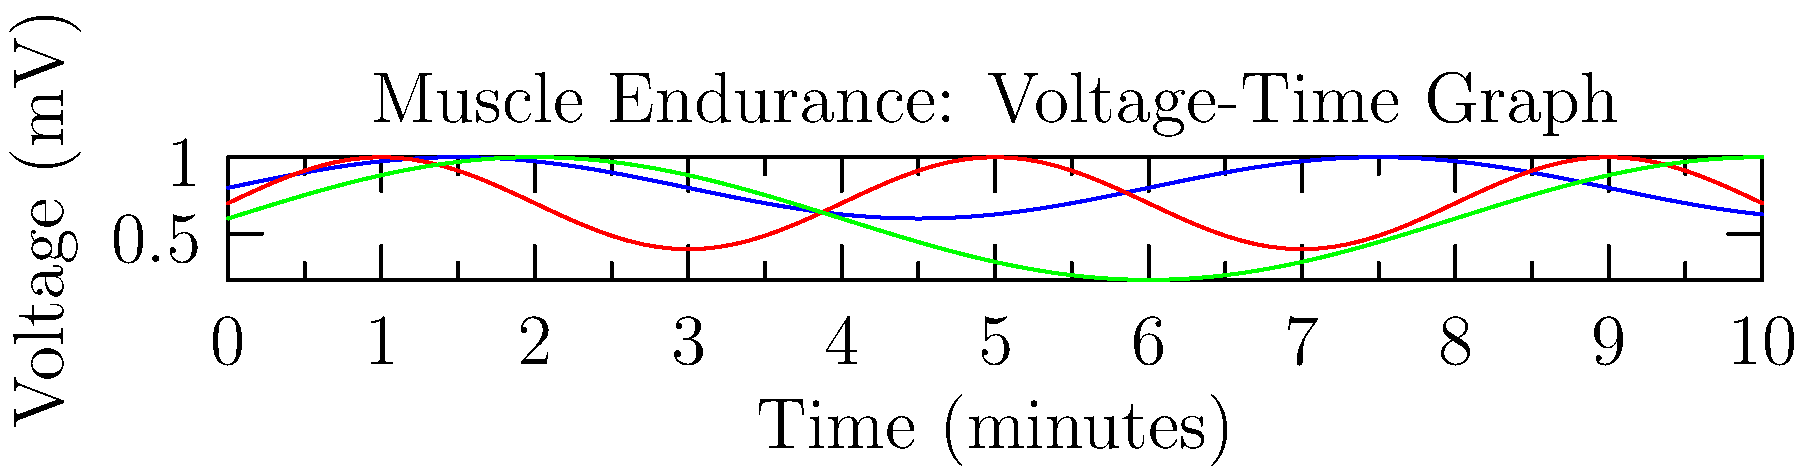Based on the voltage-time graph showing the effects of three different energy supplements on muscle endurance, which supplement appears to maintain the highest average voltage over time, indicating potentially better muscle endurance? To determine which supplement maintains the highest average voltage over time, we need to analyze the graph for each supplement:

1. Supplement A (blue line):
   - Oscillates between approximately 0.6 mV and 1.0 mV
   - Has a higher frequency of oscillation
   - Average voltage appears to be around 0.8 mV

2. Supplement B (red line):
   - Oscillates between approximately 0.4 mV and 1.0 mV
   - Has a medium frequency of oscillation
   - Average voltage appears to be around 0.7 mV

3. Supplement C (green line):
   - Oscillates between approximately 0.2 mV and 1.0 mV
   - Has a lower frequency of oscillation
   - Average voltage appears to be around 0.6 mV

By comparing these observations, we can see that Supplement A (blue line) maintains the highest average voltage over time. This suggests that Supplement A potentially provides better muscle endurance compared to the other two supplements.

The higher average voltage indicates that the muscles are able to maintain a higher level of electrical activity over time, which is often associated with improved endurance performance.
Answer: Supplement A 